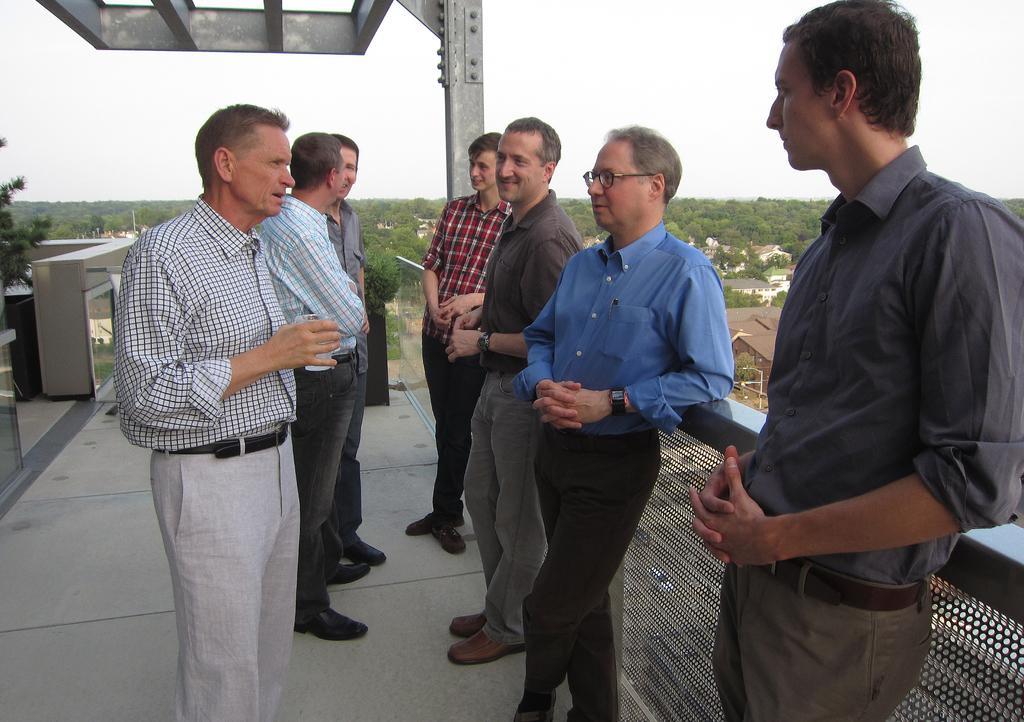Describe this image in one or two sentences. In this picture we can see few people, beside them we can see fence, in the background we can find few trees and houses. 